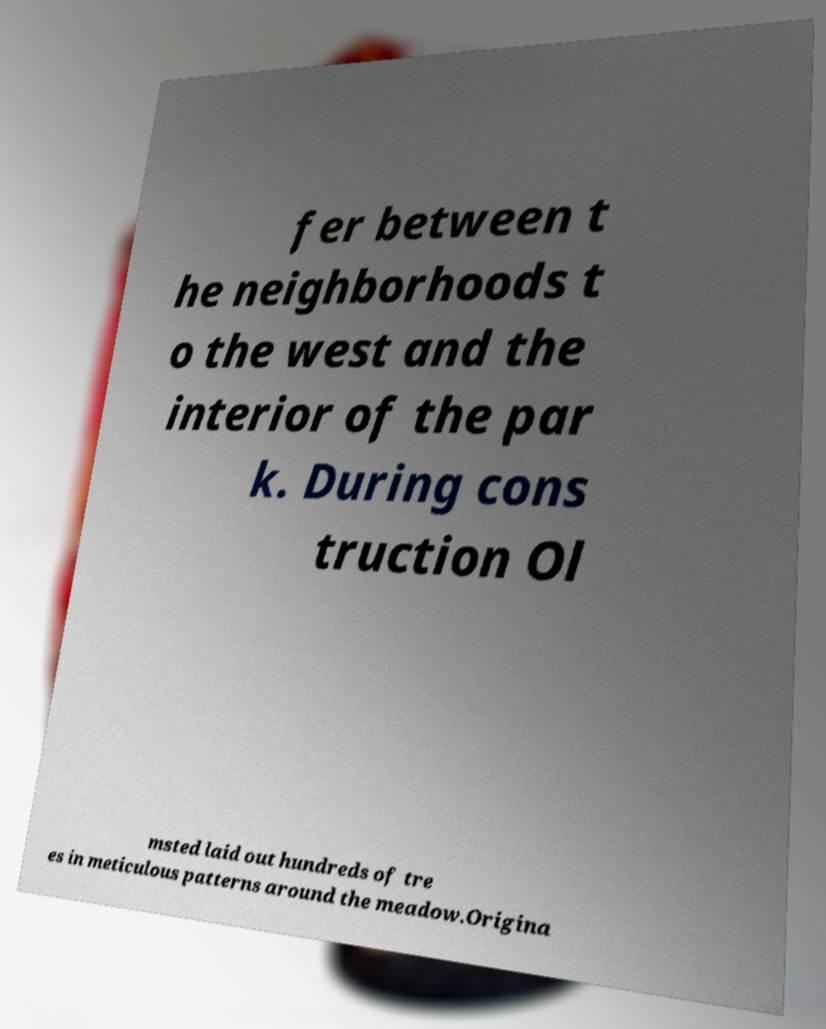Could you extract and type out the text from this image? fer between t he neighborhoods t o the west and the interior of the par k. During cons truction Ol msted laid out hundreds of tre es in meticulous patterns around the meadow.Origina 